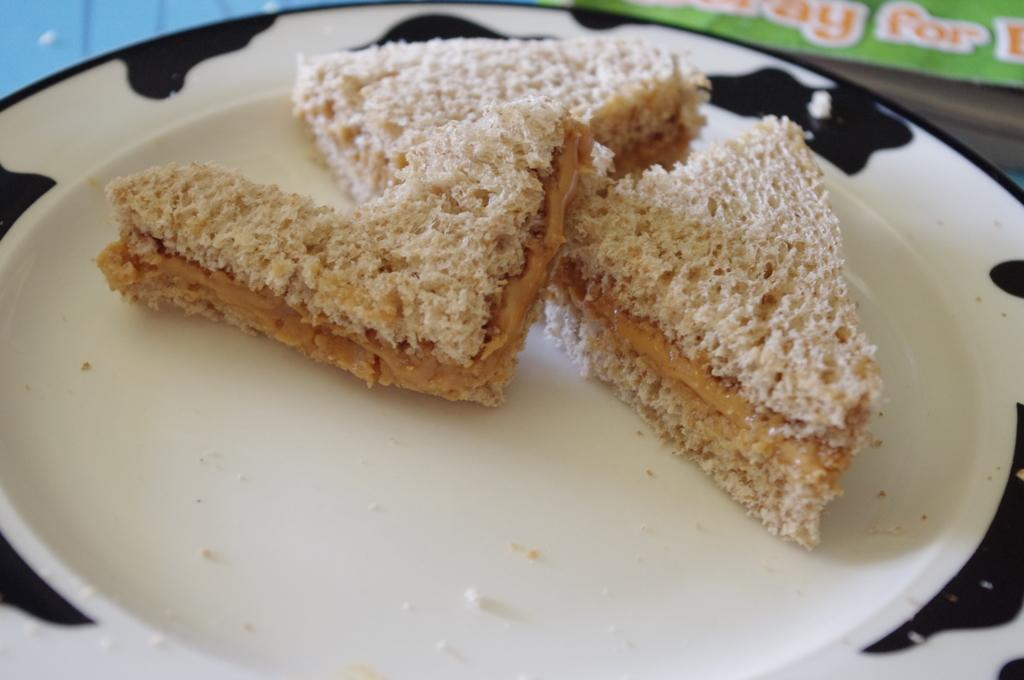What color is the plate in the image? The plate in the image is white. Are there any designs on the plate? Yes, the plate has black color designs on it. What is on the plate? There are sandwich slices on the plate. What type of rice can be seen in the image? There is no rice present in the image; it features a white plate with black designs and sandwich slices on it. 